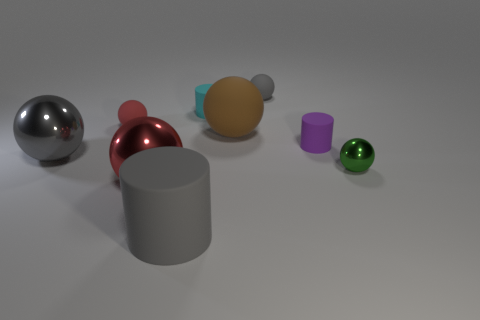How big is the matte sphere that is in front of the small cyan cylinder and on the right side of the large gray matte cylinder?
Your answer should be very brief. Large. What is the material of the tiny sphere that is the same color as the big rubber cylinder?
Ensure brevity in your answer.  Rubber. Are there the same number of brown matte things that are on the right side of the purple thing and small brown metal blocks?
Your response must be concise. Yes. Does the red rubber sphere have the same size as the gray shiny ball?
Your response must be concise. No. The object that is left of the gray cylinder and in front of the small green metallic ball is what color?
Give a very brief answer. Red. What is the big gray object behind the green metal ball that is behind the gray cylinder made of?
Offer a terse response. Metal. There is a brown object that is the same shape as the tiny red matte thing; what size is it?
Your answer should be compact. Large. There is a matte ball that is right of the brown matte ball; is it the same color as the big rubber cylinder?
Your response must be concise. Yes. Is the number of cyan matte cylinders less than the number of big brown metallic cubes?
Your answer should be very brief. No. What number of other objects are the same color as the large matte sphere?
Make the answer very short. 0. 